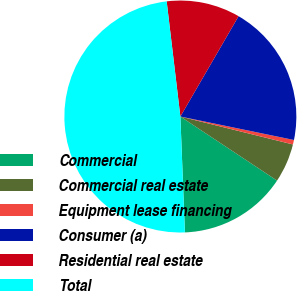<chart> <loc_0><loc_0><loc_500><loc_500><pie_chart><fcel>Commercial<fcel>Commercial real estate<fcel>Equipment lease financing<fcel>Consumer (a)<fcel>Residential real estate<fcel>Total<nl><fcel>15.06%<fcel>5.44%<fcel>0.63%<fcel>19.87%<fcel>10.25%<fcel>48.73%<nl></chart> 